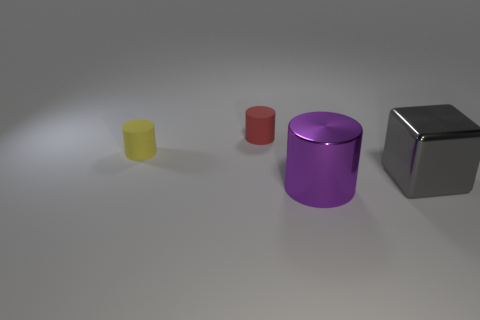Could you provide more context about what these objects might be used for? These objects appear to be simplistic representations of everyday items, potentially containers or geometric models, utilized here to display color, form, and material characteristics in a controlled lighting environment. What could the different colors of the objects suggest about their use? While the colors here might not indicate a specific use, in a practical context, objects with distinct colors could be coded to signify different contents or purposes, aiding in quick identification and sorting. 